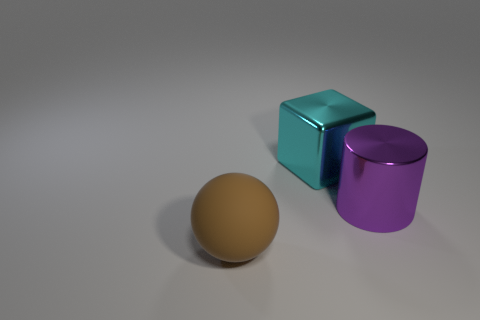How many other objects are there of the same shape as the large brown matte object?
Provide a succinct answer. 0. There is a large metallic thing behind the purple cylinder; does it have the same color as the object that is in front of the big purple shiny object?
Provide a succinct answer. No. Do the thing that is left of the big cyan metal cube and the shiny object that is right of the large cyan object have the same size?
Your answer should be compact. Yes. Is there anything else that is the same material as the cyan thing?
Offer a terse response. Yes. What material is the large thing on the right side of the big object that is behind the thing to the right of the cyan metal cube made of?
Give a very brief answer. Metal. Is the shape of the big cyan metal thing the same as the big brown rubber thing?
Your answer should be compact. No. How many big metallic blocks are the same color as the big rubber object?
Provide a succinct answer. 0. What is the size of the block that is made of the same material as the purple thing?
Offer a very short reply. Large. What number of cyan objects are cylinders or metal things?
Your answer should be compact. 1. What number of cyan metal things are on the left side of the metallic thing left of the shiny cylinder?
Your response must be concise. 0. 